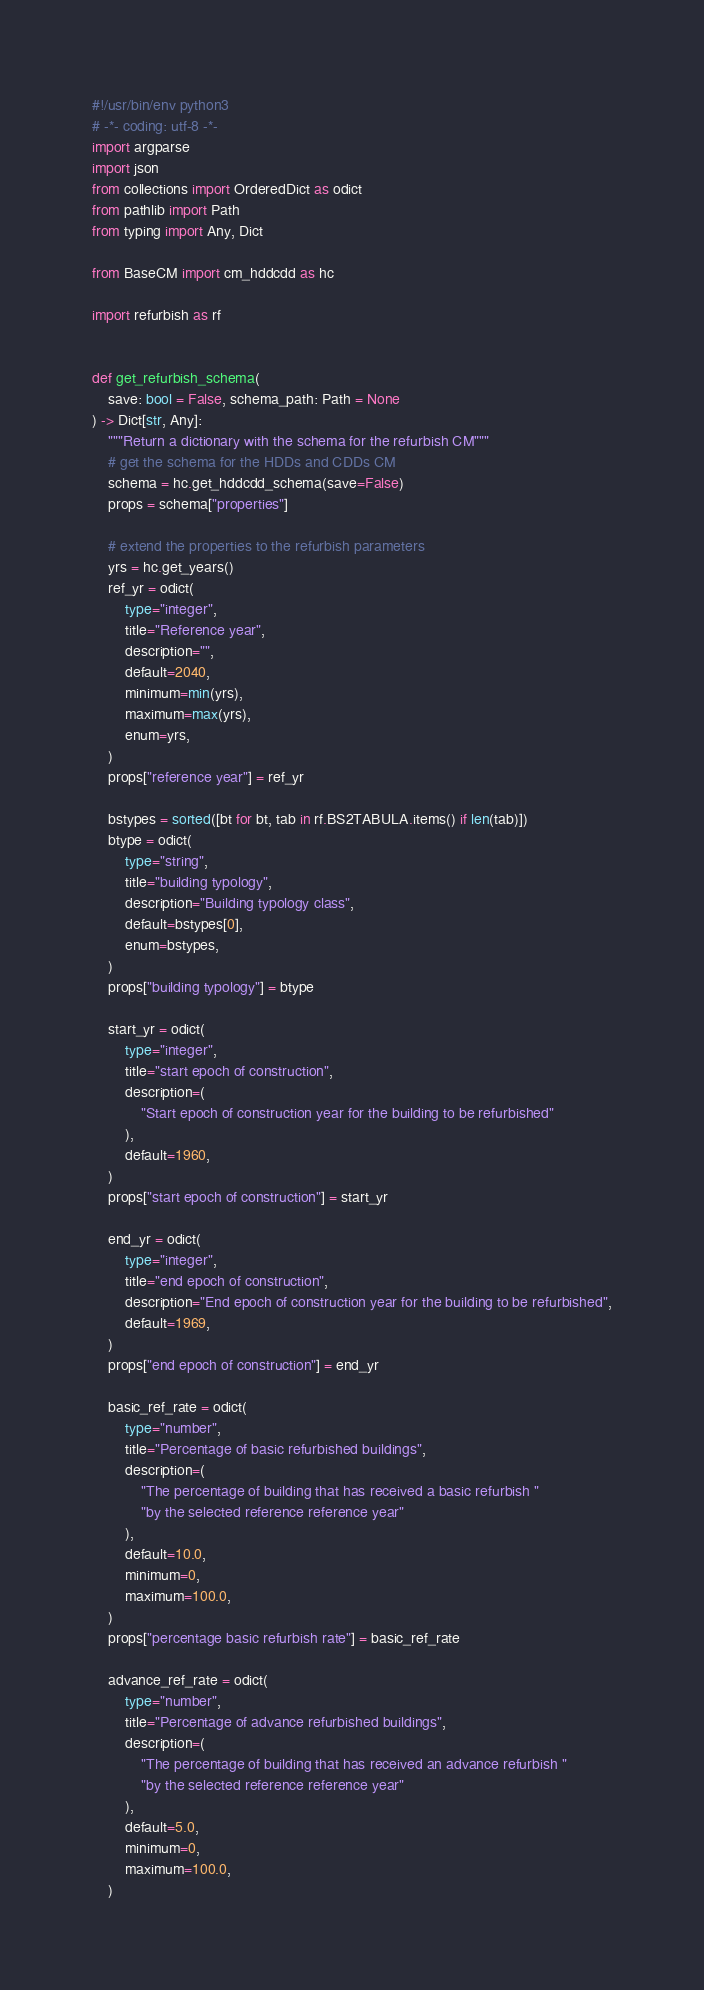Convert code to text. <code><loc_0><loc_0><loc_500><loc_500><_Python_>#!/usr/bin/env python3
# -*- coding: utf-8 -*-
import argparse
import json
from collections import OrderedDict as odict
from pathlib import Path
from typing import Any, Dict

from BaseCM import cm_hddcdd as hc

import refurbish as rf


def get_refurbish_schema(
    save: bool = False, schema_path: Path = None
) -> Dict[str, Any]:
    """Return a dictionary with the schema for the refurbish CM"""
    # get the schema for the HDDs and CDDs CM
    schema = hc.get_hddcdd_schema(save=False)
    props = schema["properties"]

    # extend the properties to the refurbish parameters
    yrs = hc.get_years()
    ref_yr = odict(
        type="integer",
        title="Reference year",
        description="",
        default=2040,
        minimum=min(yrs),
        maximum=max(yrs),
        enum=yrs,
    )
    props["reference year"] = ref_yr

    bstypes = sorted([bt for bt, tab in rf.BS2TABULA.items() if len(tab)])
    btype = odict(
        type="string",
        title="building typology",
        description="Building typology class",
        default=bstypes[0],
        enum=bstypes,
    )
    props["building typology"] = btype

    start_yr = odict(
        type="integer",
        title="start epoch of construction",
        description=(
            "Start epoch of construction year for the building to be refurbished"
        ),
        default=1960,
    )
    props["start epoch of construction"] = start_yr

    end_yr = odict(
        type="integer",
        title="end epoch of construction",
        description="End epoch of construction year for the building to be refurbished",
        default=1969,
    )
    props["end epoch of construction"] = end_yr

    basic_ref_rate = odict(
        type="number",
        title="Percentage of basic refurbished buildings",
        description=(
            "The percentage of building that has received a basic refurbish "
            "by the selected reference reference year"
        ),
        default=10.0,
        minimum=0,
        maximum=100.0,
    )
    props["percentage basic refurbish rate"] = basic_ref_rate

    advance_ref_rate = odict(
        type="number",
        title="Percentage of advance refurbished buildings",
        description=(
            "The percentage of building that has received an advance refurbish "
            "by the selected reference reference year"
        ),
        default=5.0,
        minimum=0,
        maximum=100.0,
    )</code> 